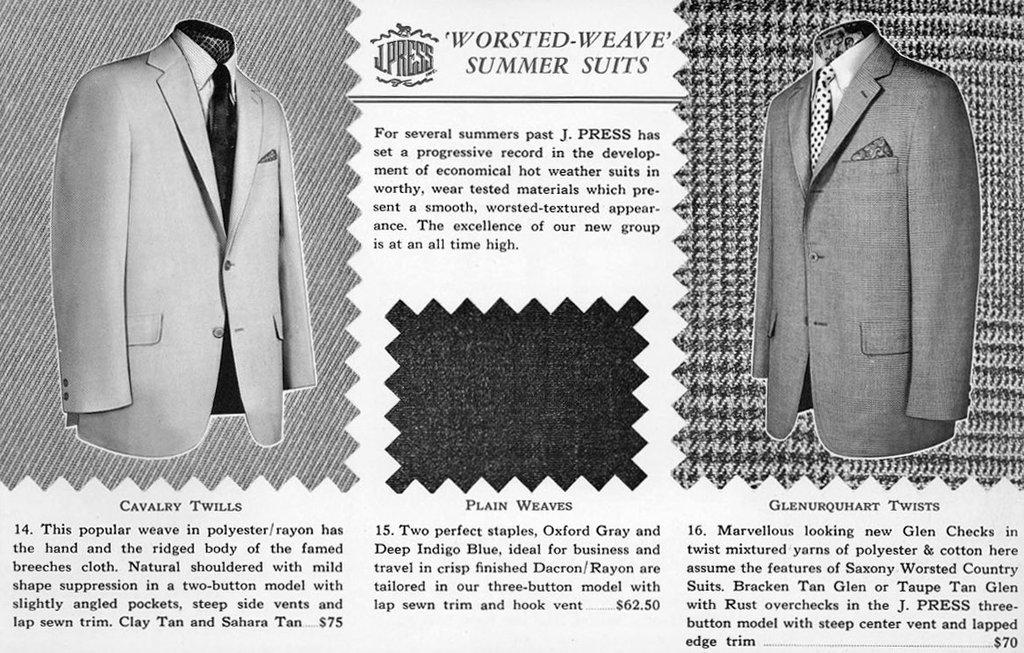What is present in the image? There is a paper in the image. What is depicted on the paper? The paper has pictures of suits on it. What type of baseball equipment can be seen in the image? There is no baseball equipment present in the image. What type of vegetable is depicted on the paper in the image? There is no vegetable, such as cabbage, depicted on the paper in the image. What type of musical instrument is shown being played in the image? There is no musical instrument, such as a guitar, shown being played in the image. 